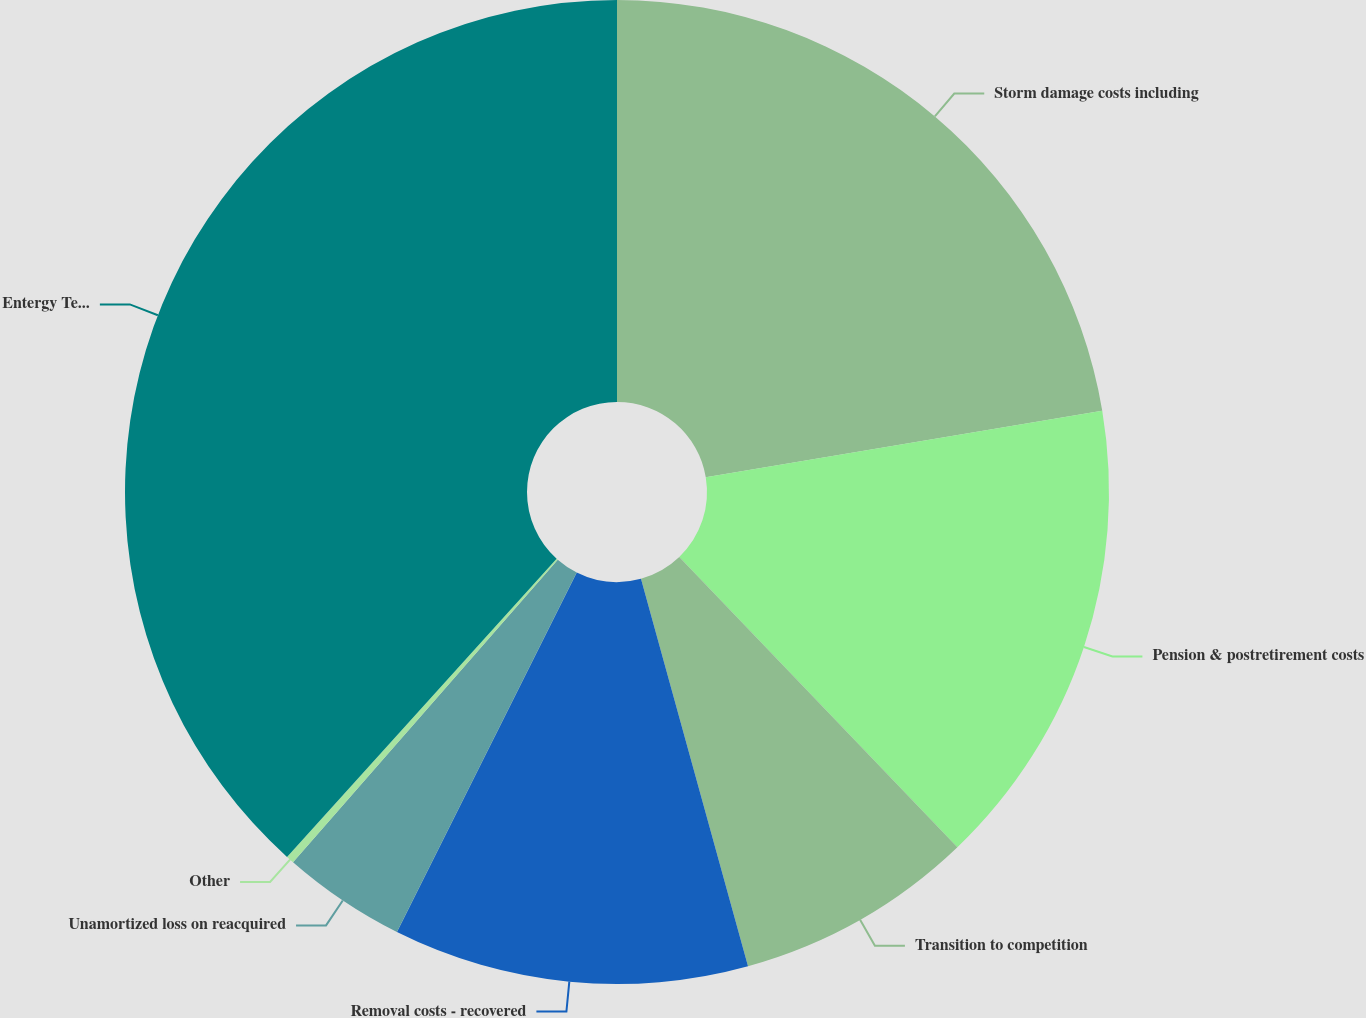Convert chart to OTSL. <chart><loc_0><loc_0><loc_500><loc_500><pie_chart><fcel>Storm damage costs including<fcel>Pension & postretirement costs<fcel>Transition to competition<fcel>Removal costs - recovered<fcel>Unamortized loss on reacquired<fcel>Other<fcel>Entergy Texas Total<nl><fcel>22.36%<fcel>15.48%<fcel>7.87%<fcel>11.67%<fcel>4.06%<fcel>0.26%<fcel>38.3%<nl></chart> 